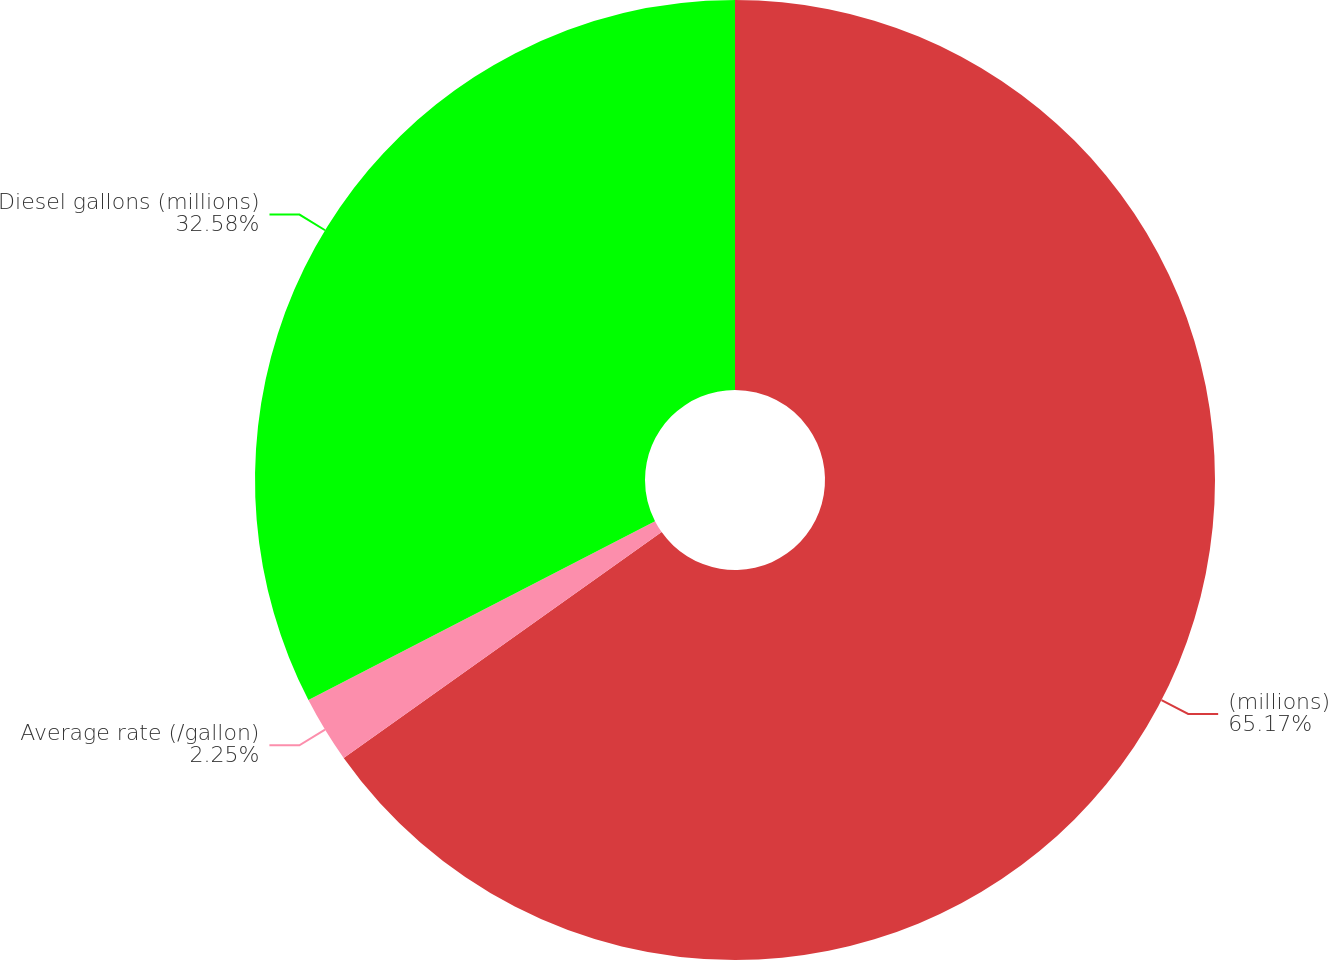Convert chart. <chart><loc_0><loc_0><loc_500><loc_500><pie_chart><fcel>(millions)<fcel>Average rate (/gallon)<fcel>Diesel gallons (millions)<nl><fcel>65.17%<fcel>2.25%<fcel>32.58%<nl></chart> 